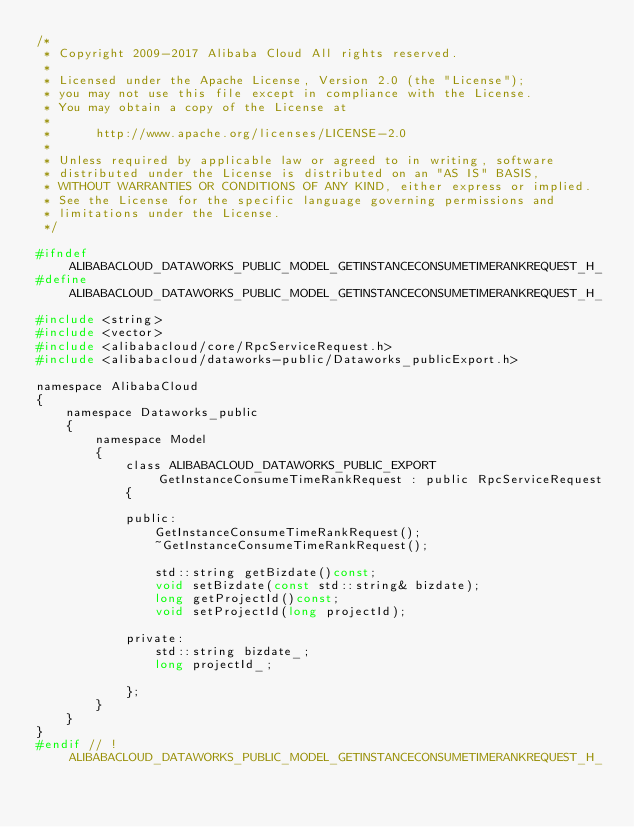<code> <loc_0><loc_0><loc_500><loc_500><_C_>/*
 * Copyright 2009-2017 Alibaba Cloud All rights reserved.
 * 
 * Licensed under the Apache License, Version 2.0 (the "License");
 * you may not use this file except in compliance with the License.
 * You may obtain a copy of the License at
 * 
 *      http://www.apache.org/licenses/LICENSE-2.0
 * 
 * Unless required by applicable law or agreed to in writing, software
 * distributed under the License is distributed on an "AS IS" BASIS,
 * WITHOUT WARRANTIES OR CONDITIONS OF ANY KIND, either express or implied.
 * See the License for the specific language governing permissions and
 * limitations under the License.
 */

#ifndef ALIBABACLOUD_DATAWORKS_PUBLIC_MODEL_GETINSTANCECONSUMETIMERANKREQUEST_H_
#define ALIBABACLOUD_DATAWORKS_PUBLIC_MODEL_GETINSTANCECONSUMETIMERANKREQUEST_H_

#include <string>
#include <vector>
#include <alibabacloud/core/RpcServiceRequest.h>
#include <alibabacloud/dataworks-public/Dataworks_publicExport.h>

namespace AlibabaCloud
{
	namespace Dataworks_public
	{
		namespace Model
		{
			class ALIBABACLOUD_DATAWORKS_PUBLIC_EXPORT GetInstanceConsumeTimeRankRequest : public RpcServiceRequest
			{

			public:
				GetInstanceConsumeTimeRankRequest();
				~GetInstanceConsumeTimeRankRequest();

				std::string getBizdate()const;
				void setBizdate(const std::string& bizdate);
				long getProjectId()const;
				void setProjectId(long projectId);

            private:
				std::string bizdate_;
				long projectId_;

			};
		}
	}
}
#endif // !ALIBABACLOUD_DATAWORKS_PUBLIC_MODEL_GETINSTANCECONSUMETIMERANKREQUEST_H_</code> 